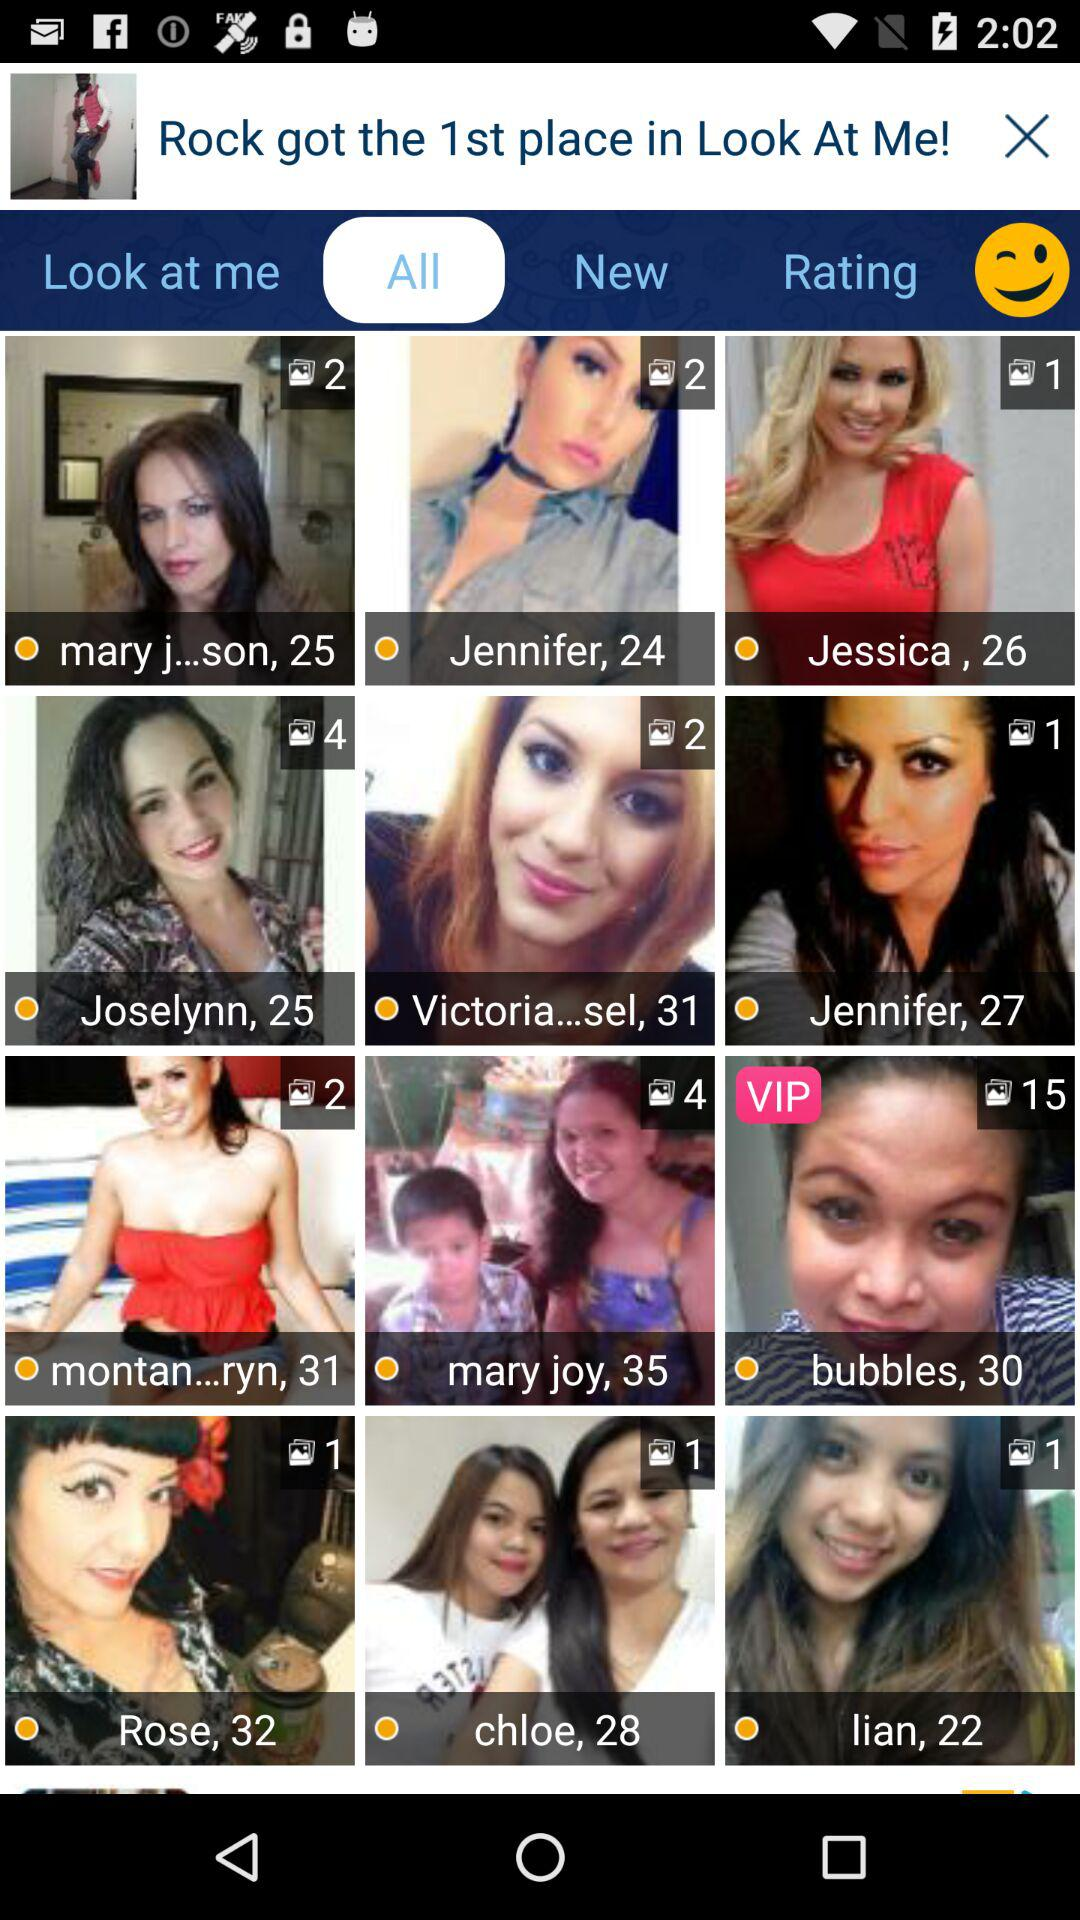What is the age of Jessica? Jessica is 26 years old. 